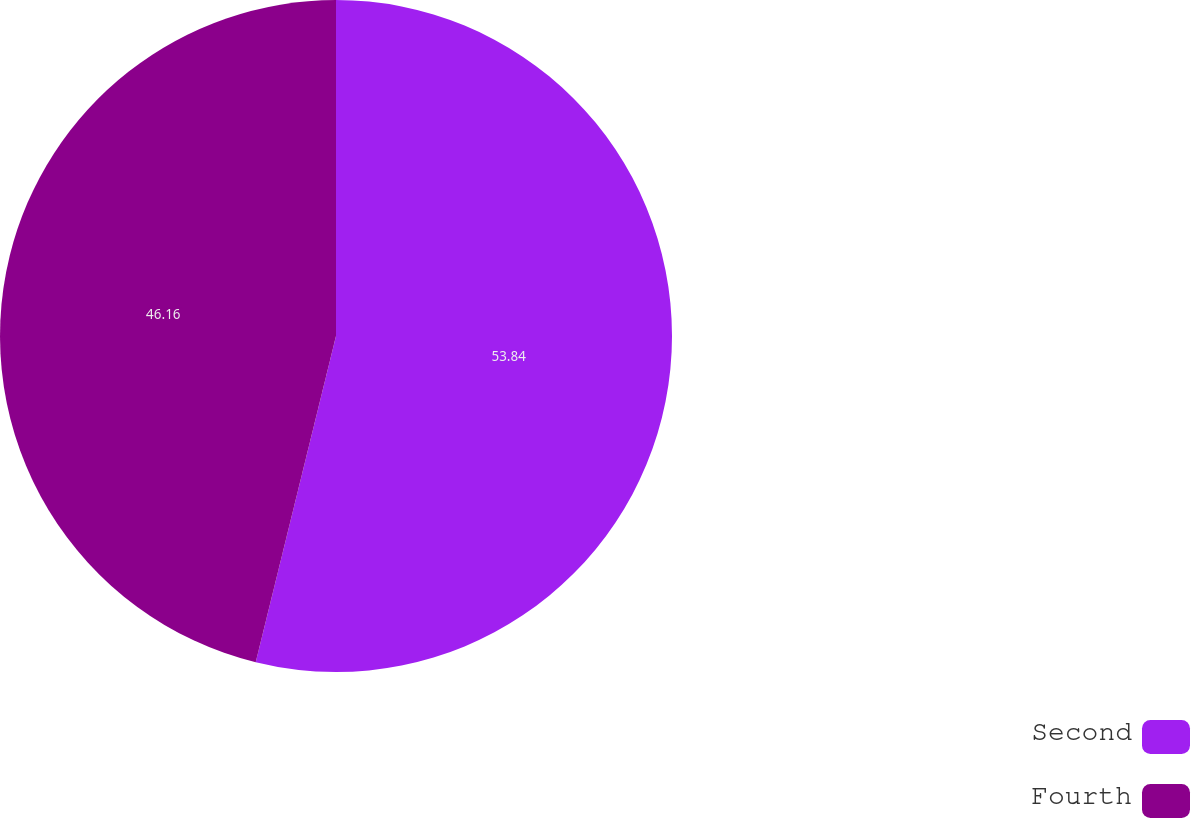Convert chart to OTSL. <chart><loc_0><loc_0><loc_500><loc_500><pie_chart><fcel>Second<fcel>Fourth<nl><fcel>53.84%<fcel>46.16%<nl></chart> 